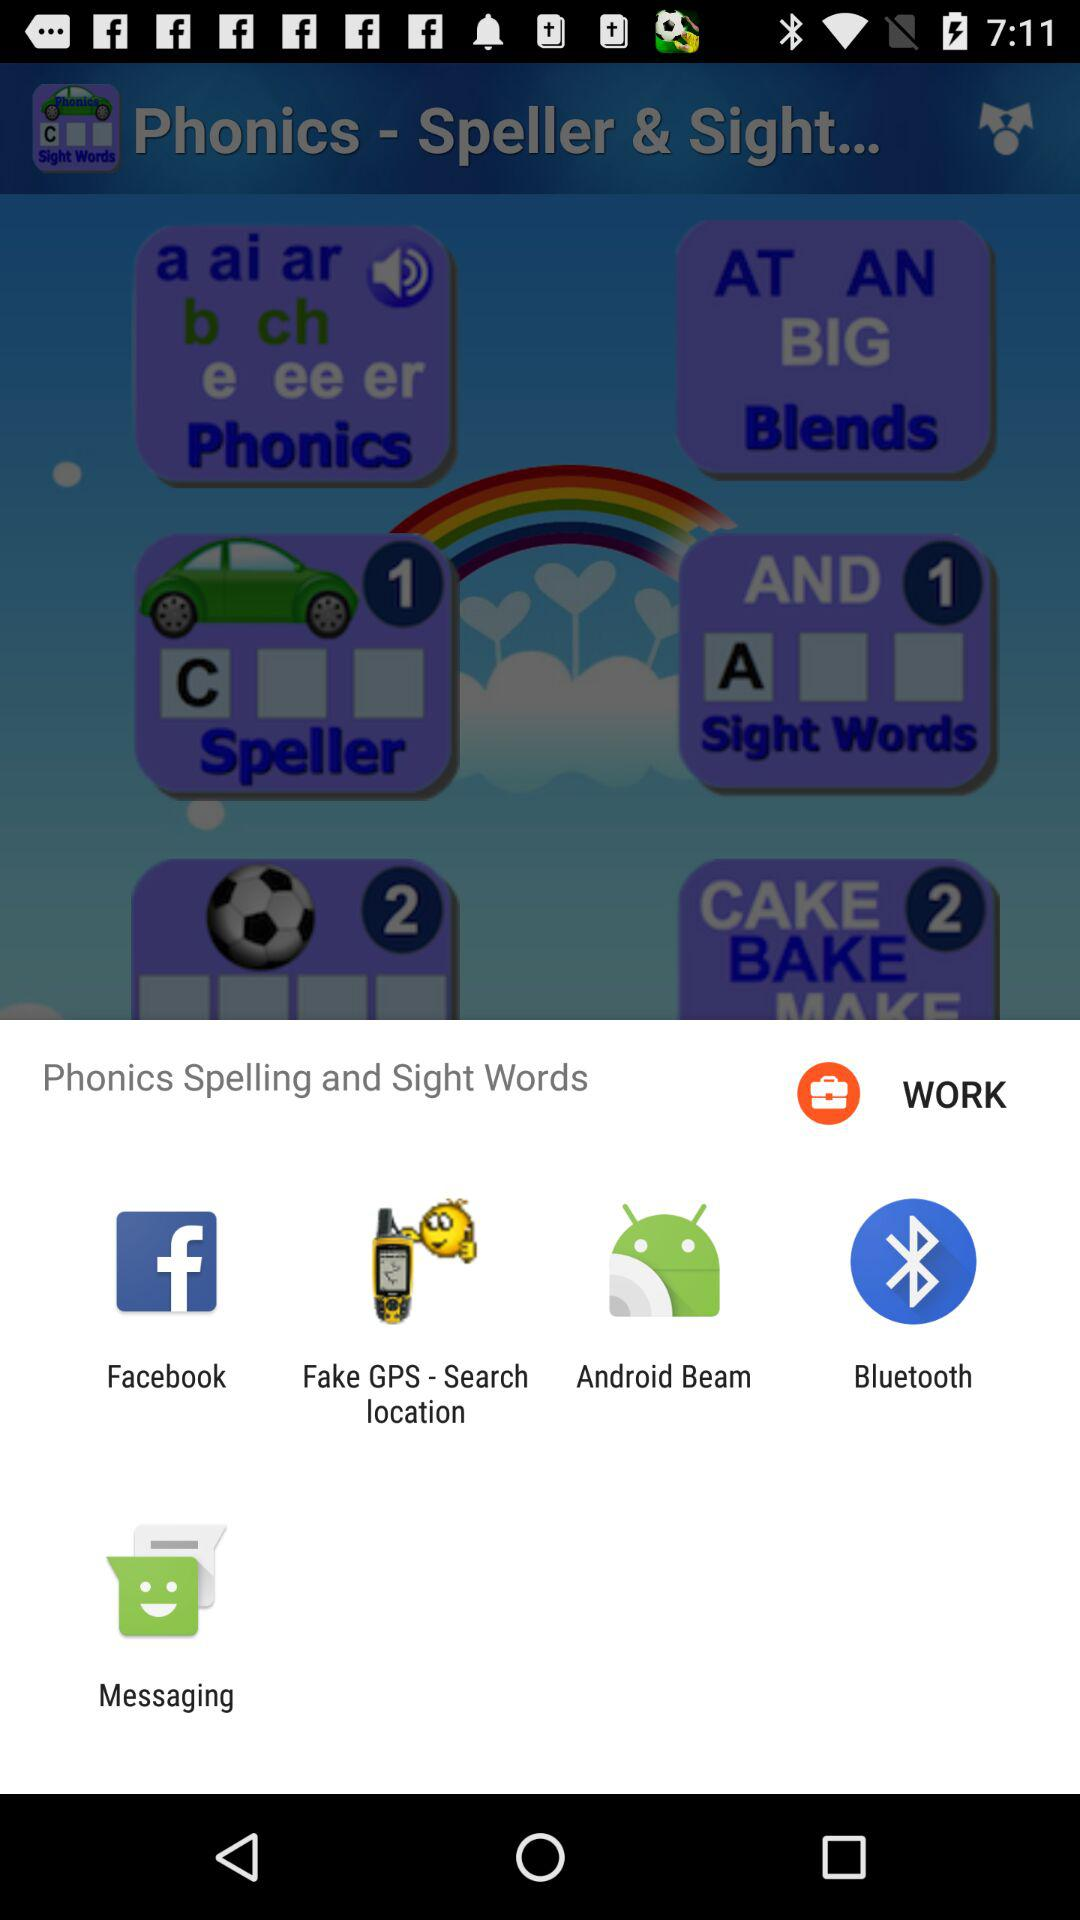What applications are used to share? The applications are "Facebook", "Fake GPS - Search location", "Android Beam", "Bluetooth", and "Messaging". 